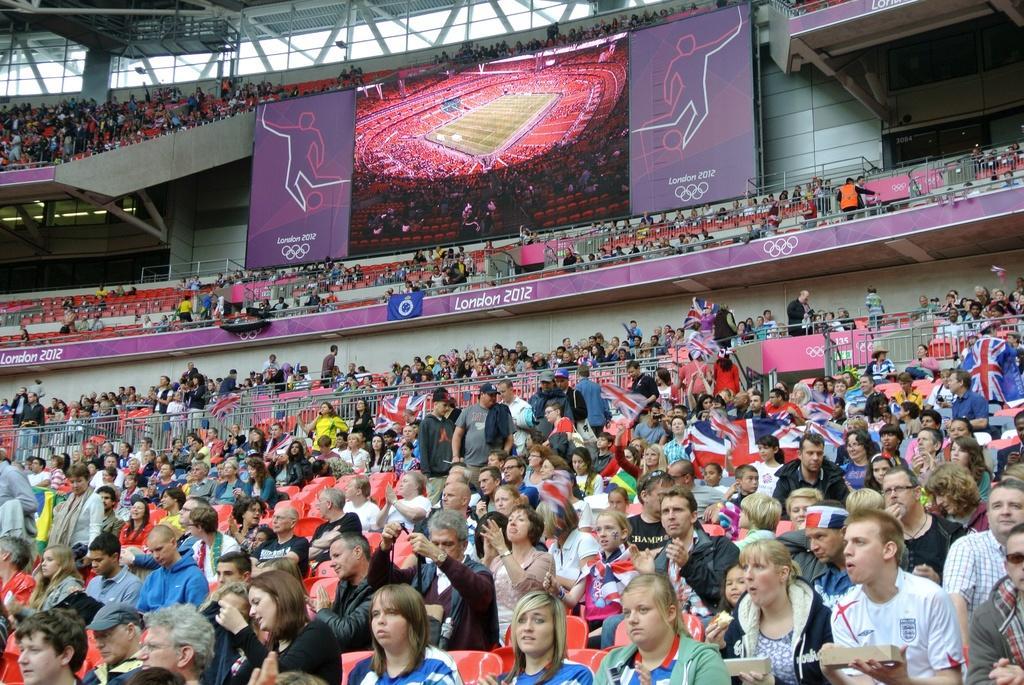How would you summarize this image in a sentence or two? In this image I can see number of people are sitting in chairs which are red in color in the stadium. I can see few flags, few boards, few banners, a huge screen in which I can see the stadium and the ceiling of the stadium. 